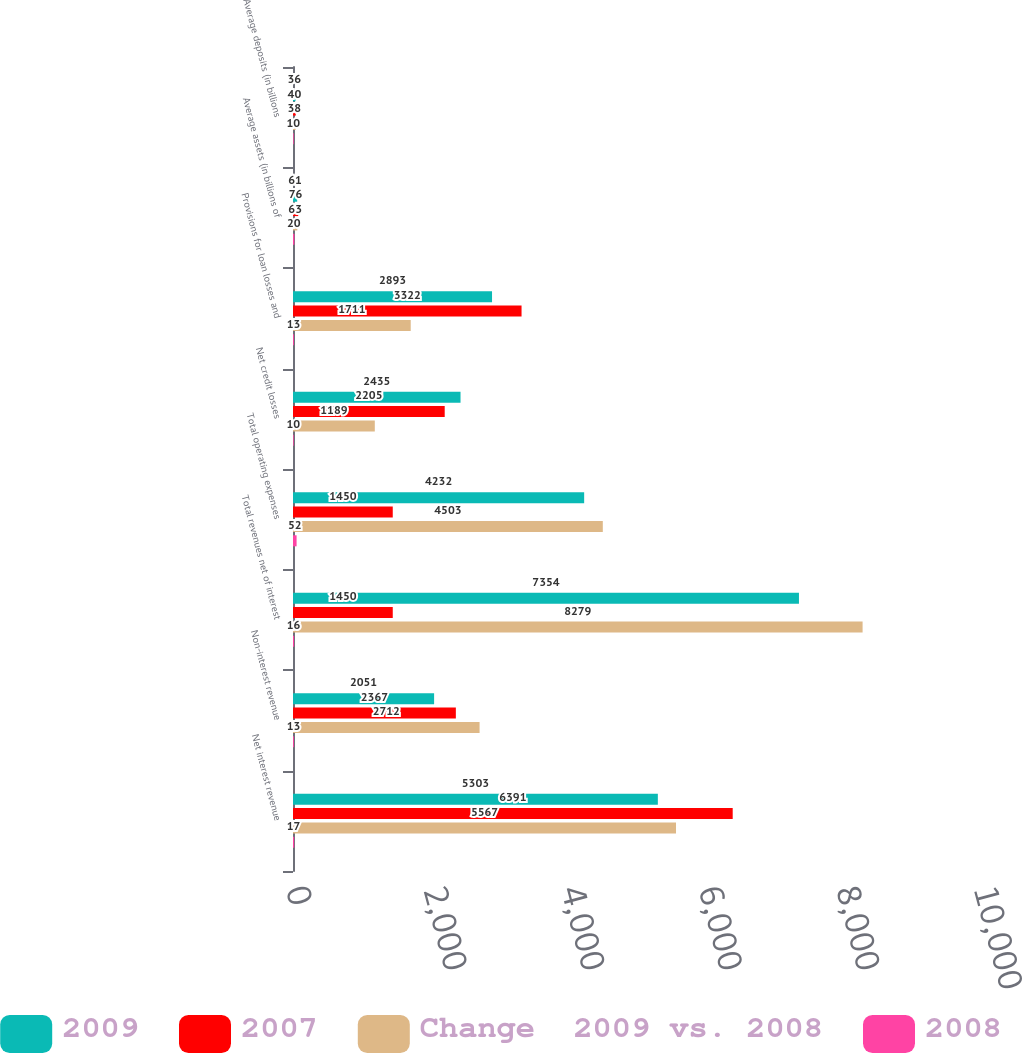<chart> <loc_0><loc_0><loc_500><loc_500><stacked_bar_chart><ecel><fcel>Net interest revenue<fcel>Non-interest revenue<fcel>Total revenues net of interest<fcel>Total operating expenses<fcel>Net credit losses<fcel>Provisions for loan losses and<fcel>Average assets (in billions of<fcel>Average deposits (in billions<nl><fcel>2009<fcel>5303<fcel>2051<fcel>7354<fcel>4232<fcel>2435<fcel>2893<fcel>61<fcel>36<nl><fcel>2007<fcel>6391<fcel>2367<fcel>1450<fcel>1450<fcel>2205<fcel>3322<fcel>76<fcel>40<nl><fcel>Change  2009 vs. 2008<fcel>5567<fcel>2712<fcel>8279<fcel>4503<fcel>1189<fcel>1711<fcel>63<fcel>38<nl><fcel>2008<fcel>17<fcel>13<fcel>16<fcel>52<fcel>10<fcel>13<fcel>20<fcel>10<nl></chart> 